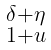Convert formula to latex. <formula><loc_0><loc_0><loc_500><loc_500>\begin{smallmatrix} \delta + \eta \\ 1 + u \end{smallmatrix}</formula> 